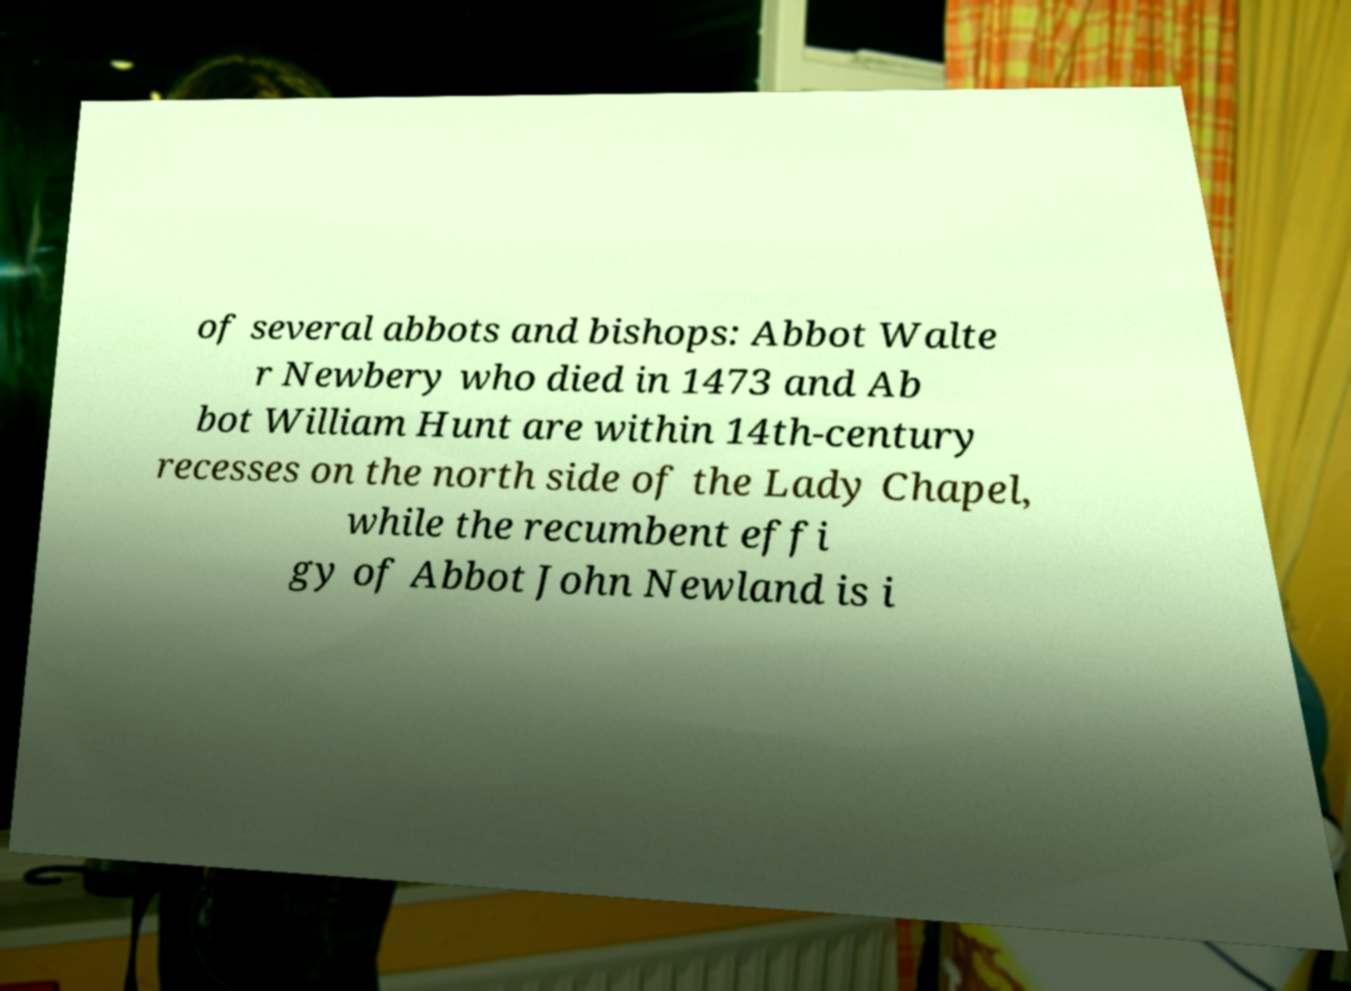What messages or text are displayed in this image? I need them in a readable, typed format. of several abbots and bishops: Abbot Walte r Newbery who died in 1473 and Ab bot William Hunt are within 14th-century recesses on the north side of the Lady Chapel, while the recumbent effi gy of Abbot John Newland is i 